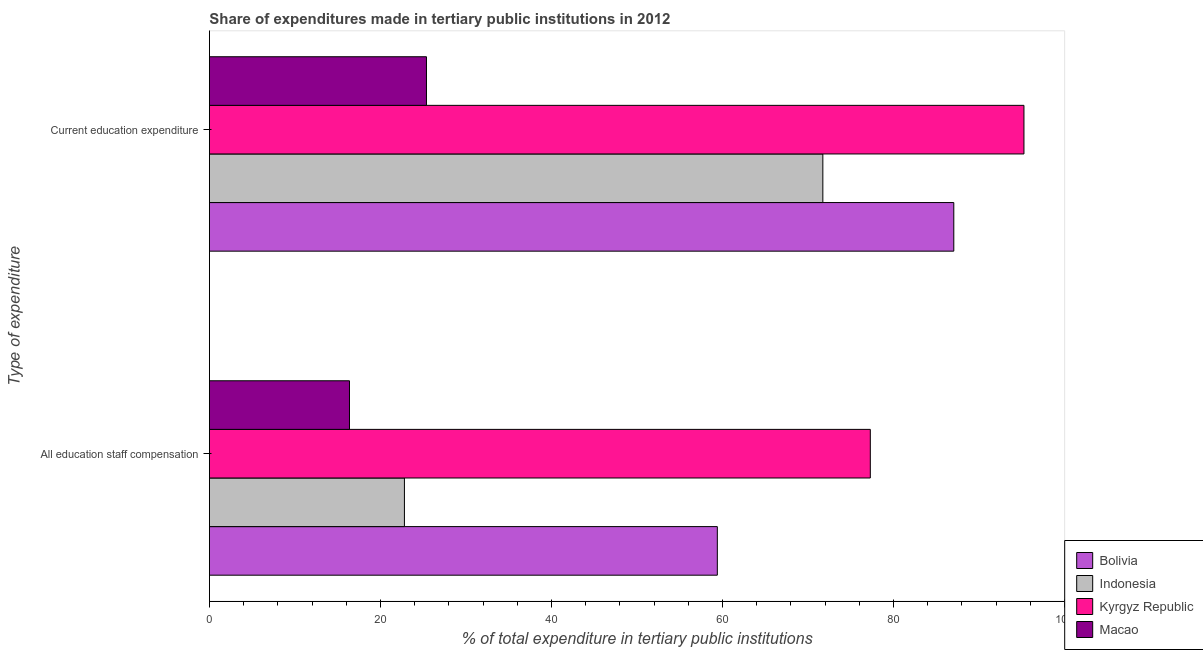How many different coloured bars are there?
Keep it short and to the point. 4. Are the number of bars per tick equal to the number of legend labels?
Ensure brevity in your answer.  Yes. Are the number of bars on each tick of the Y-axis equal?
Provide a short and direct response. Yes. How many bars are there on the 2nd tick from the bottom?
Offer a very short reply. 4. What is the label of the 1st group of bars from the top?
Your answer should be compact. Current education expenditure. What is the expenditure in staff compensation in Bolivia?
Ensure brevity in your answer.  59.4. Across all countries, what is the maximum expenditure in education?
Offer a very short reply. 95.26. Across all countries, what is the minimum expenditure in education?
Offer a very short reply. 25.39. In which country was the expenditure in education maximum?
Provide a short and direct response. Kyrgyz Republic. In which country was the expenditure in education minimum?
Your response must be concise. Macao. What is the total expenditure in staff compensation in the graph?
Give a very brief answer. 175.88. What is the difference between the expenditure in education in Indonesia and that in Bolivia?
Give a very brief answer. -15.32. What is the difference between the expenditure in staff compensation in Macao and the expenditure in education in Indonesia?
Provide a succinct answer. -55.36. What is the average expenditure in staff compensation per country?
Offer a terse response. 43.97. What is the difference between the expenditure in education and expenditure in staff compensation in Bolivia?
Ensure brevity in your answer.  27.66. What is the ratio of the expenditure in staff compensation in Macao to that in Kyrgyz Republic?
Offer a very short reply. 0.21. Is the expenditure in education in Indonesia less than that in Bolivia?
Provide a short and direct response. Yes. In how many countries, is the expenditure in education greater than the average expenditure in education taken over all countries?
Ensure brevity in your answer.  3. What does the 4th bar from the top in Current education expenditure represents?
Your answer should be very brief. Bolivia. Are the values on the major ticks of X-axis written in scientific E-notation?
Make the answer very short. No. Does the graph contain grids?
Offer a very short reply. No. How many legend labels are there?
Make the answer very short. 4. How are the legend labels stacked?
Provide a short and direct response. Vertical. What is the title of the graph?
Your answer should be compact. Share of expenditures made in tertiary public institutions in 2012. Does "Portugal" appear as one of the legend labels in the graph?
Provide a succinct answer. No. What is the label or title of the X-axis?
Your response must be concise. % of total expenditure in tertiary public institutions. What is the label or title of the Y-axis?
Give a very brief answer. Type of expenditure. What is the % of total expenditure in tertiary public institutions of Bolivia in All education staff compensation?
Ensure brevity in your answer.  59.4. What is the % of total expenditure in tertiary public institutions in Indonesia in All education staff compensation?
Provide a short and direct response. 22.81. What is the % of total expenditure in tertiary public institutions in Kyrgyz Republic in All education staff compensation?
Provide a short and direct response. 77.29. What is the % of total expenditure in tertiary public institutions of Macao in All education staff compensation?
Ensure brevity in your answer.  16.38. What is the % of total expenditure in tertiary public institutions of Bolivia in Current education expenditure?
Provide a succinct answer. 87.06. What is the % of total expenditure in tertiary public institutions of Indonesia in Current education expenditure?
Offer a terse response. 71.74. What is the % of total expenditure in tertiary public institutions in Kyrgyz Republic in Current education expenditure?
Keep it short and to the point. 95.26. What is the % of total expenditure in tertiary public institutions in Macao in Current education expenditure?
Your answer should be very brief. 25.39. Across all Type of expenditure, what is the maximum % of total expenditure in tertiary public institutions of Bolivia?
Provide a short and direct response. 87.06. Across all Type of expenditure, what is the maximum % of total expenditure in tertiary public institutions of Indonesia?
Your response must be concise. 71.74. Across all Type of expenditure, what is the maximum % of total expenditure in tertiary public institutions in Kyrgyz Republic?
Offer a terse response. 95.26. Across all Type of expenditure, what is the maximum % of total expenditure in tertiary public institutions in Macao?
Ensure brevity in your answer.  25.39. Across all Type of expenditure, what is the minimum % of total expenditure in tertiary public institutions of Bolivia?
Your answer should be very brief. 59.4. Across all Type of expenditure, what is the minimum % of total expenditure in tertiary public institutions in Indonesia?
Provide a short and direct response. 22.81. Across all Type of expenditure, what is the minimum % of total expenditure in tertiary public institutions in Kyrgyz Republic?
Offer a very short reply. 77.29. Across all Type of expenditure, what is the minimum % of total expenditure in tertiary public institutions in Macao?
Offer a terse response. 16.38. What is the total % of total expenditure in tertiary public institutions in Bolivia in the graph?
Offer a very short reply. 146.46. What is the total % of total expenditure in tertiary public institutions of Indonesia in the graph?
Make the answer very short. 94.55. What is the total % of total expenditure in tertiary public institutions of Kyrgyz Republic in the graph?
Your answer should be very brief. 172.56. What is the total % of total expenditure in tertiary public institutions of Macao in the graph?
Keep it short and to the point. 41.77. What is the difference between the % of total expenditure in tertiary public institutions in Bolivia in All education staff compensation and that in Current education expenditure?
Offer a very short reply. -27.66. What is the difference between the % of total expenditure in tertiary public institutions of Indonesia in All education staff compensation and that in Current education expenditure?
Offer a terse response. -48.94. What is the difference between the % of total expenditure in tertiary public institutions in Kyrgyz Republic in All education staff compensation and that in Current education expenditure?
Give a very brief answer. -17.97. What is the difference between the % of total expenditure in tertiary public institutions in Macao in All education staff compensation and that in Current education expenditure?
Your answer should be compact. -9. What is the difference between the % of total expenditure in tertiary public institutions of Bolivia in All education staff compensation and the % of total expenditure in tertiary public institutions of Indonesia in Current education expenditure?
Give a very brief answer. -12.34. What is the difference between the % of total expenditure in tertiary public institutions of Bolivia in All education staff compensation and the % of total expenditure in tertiary public institutions of Kyrgyz Republic in Current education expenditure?
Keep it short and to the point. -35.86. What is the difference between the % of total expenditure in tertiary public institutions in Bolivia in All education staff compensation and the % of total expenditure in tertiary public institutions in Macao in Current education expenditure?
Give a very brief answer. 34.02. What is the difference between the % of total expenditure in tertiary public institutions of Indonesia in All education staff compensation and the % of total expenditure in tertiary public institutions of Kyrgyz Republic in Current education expenditure?
Give a very brief answer. -72.46. What is the difference between the % of total expenditure in tertiary public institutions of Indonesia in All education staff compensation and the % of total expenditure in tertiary public institutions of Macao in Current education expenditure?
Your response must be concise. -2.58. What is the difference between the % of total expenditure in tertiary public institutions in Kyrgyz Republic in All education staff compensation and the % of total expenditure in tertiary public institutions in Macao in Current education expenditure?
Keep it short and to the point. 51.91. What is the average % of total expenditure in tertiary public institutions in Bolivia per Type of expenditure?
Offer a terse response. 73.23. What is the average % of total expenditure in tertiary public institutions in Indonesia per Type of expenditure?
Provide a short and direct response. 47.27. What is the average % of total expenditure in tertiary public institutions of Kyrgyz Republic per Type of expenditure?
Your response must be concise. 86.28. What is the average % of total expenditure in tertiary public institutions of Macao per Type of expenditure?
Make the answer very short. 20.88. What is the difference between the % of total expenditure in tertiary public institutions in Bolivia and % of total expenditure in tertiary public institutions in Indonesia in All education staff compensation?
Ensure brevity in your answer.  36.6. What is the difference between the % of total expenditure in tertiary public institutions in Bolivia and % of total expenditure in tertiary public institutions in Kyrgyz Republic in All education staff compensation?
Make the answer very short. -17.89. What is the difference between the % of total expenditure in tertiary public institutions of Bolivia and % of total expenditure in tertiary public institutions of Macao in All education staff compensation?
Your answer should be compact. 43.02. What is the difference between the % of total expenditure in tertiary public institutions of Indonesia and % of total expenditure in tertiary public institutions of Kyrgyz Republic in All education staff compensation?
Give a very brief answer. -54.49. What is the difference between the % of total expenditure in tertiary public institutions in Indonesia and % of total expenditure in tertiary public institutions in Macao in All education staff compensation?
Make the answer very short. 6.43. What is the difference between the % of total expenditure in tertiary public institutions in Kyrgyz Republic and % of total expenditure in tertiary public institutions in Macao in All education staff compensation?
Ensure brevity in your answer.  60.91. What is the difference between the % of total expenditure in tertiary public institutions of Bolivia and % of total expenditure in tertiary public institutions of Indonesia in Current education expenditure?
Provide a succinct answer. 15.32. What is the difference between the % of total expenditure in tertiary public institutions of Bolivia and % of total expenditure in tertiary public institutions of Kyrgyz Republic in Current education expenditure?
Keep it short and to the point. -8.2. What is the difference between the % of total expenditure in tertiary public institutions of Bolivia and % of total expenditure in tertiary public institutions of Macao in Current education expenditure?
Ensure brevity in your answer.  61.67. What is the difference between the % of total expenditure in tertiary public institutions of Indonesia and % of total expenditure in tertiary public institutions of Kyrgyz Republic in Current education expenditure?
Your response must be concise. -23.52. What is the difference between the % of total expenditure in tertiary public institutions in Indonesia and % of total expenditure in tertiary public institutions in Macao in Current education expenditure?
Your answer should be compact. 46.36. What is the difference between the % of total expenditure in tertiary public institutions of Kyrgyz Republic and % of total expenditure in tertiary public institutions of Macao in Current education expenditure?
Ensure brevity in your answer.  69.88. What is the ratio of the % of total expenditure in tertiary public institutions in Bolivia in All education staff compensation to that in Current education expenditure?
Provide a succinct answer. 0.68. What is the ratio of the % of total expenditure in tertiary public institutions of Indonesia in All education staff compensation to that in Current education expenditure?
Make the answer very short. 0.32. What is the ratio of the % of total expenditure in tertiary public institutions in Kyrgyz Republic in All education staff compensation to that in Current education expenditure?
Make the answer very short. 0.81. What is the ratio of the % of total expenditure in tertiary public institutions in Macao in All education staff compensation to that in Current education expenditure?
Make the answer very short. 0.65. What is the difference between the highest and the second highest % of total expenditure in tertiary public institutions of Bolivia?
Make the answer very short. 27.66. What is the difference between the highest and the second highest % of total expenditure in tertiary public institutions in Indonesia?
Your answer should be very brief. 48.94. What is the difference between the highest and the second highest % of total expenditure in tertiary public institutions of Kyrgyz Republic?
Offer a terse response. 17.97. What is the difference between the highest and the second highest % of total expenditure in tertiary public institutions of Macao?
Offer a terse response. 9. What is the difference between the highest and the lowest % of total expenditure in tertiary public institutions in Bolivia?
Ensure brevity in your answer.  27.66. What is the difference between the highest and the lowest % of total expenditure in tertiary public institutions of Indonesia?
Offer a terse response. 48.94. What is the difference between the highest and the lowest % of total expenditure in tertiary public institutions in Kyrgyz Republic?
Make the answer very short. 17.97. What is the difference between the highest and the lowest % of total expenditure in tertiary public institutions in Macao?
Provide a short and direct response. 9. 